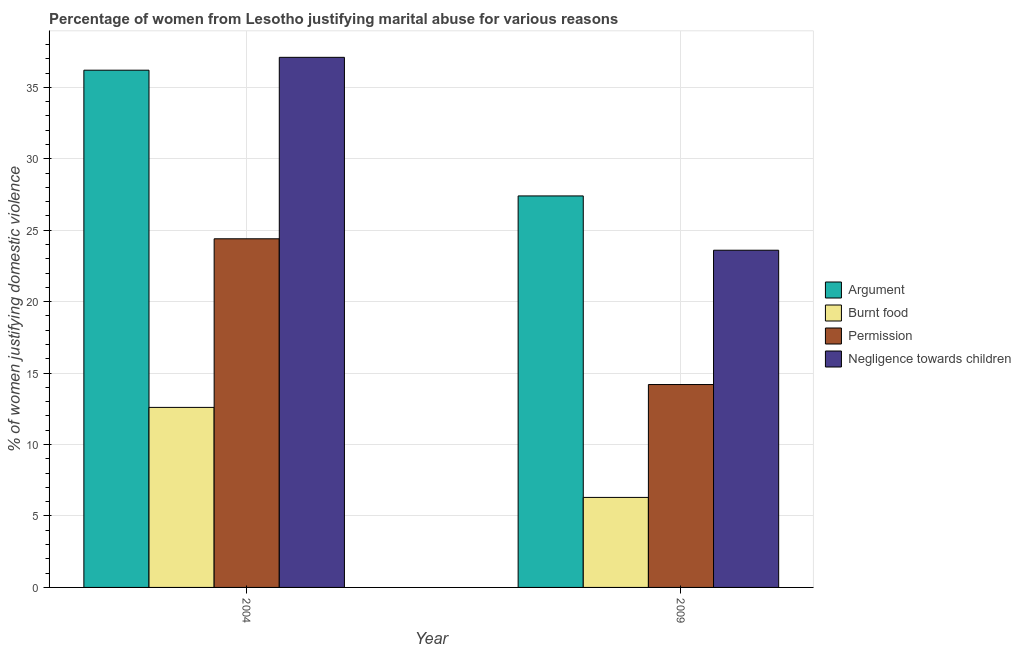How many different coloured bars are there?
Ensure brevity in your answer.  4. How many groups of bars are there?
Keep it short and to the point. 2. Are the number of bars on each tick of the X-axis equal?
Provide a succinct answer. Yes. How many bars are there on the 2nd tick from the left?
Offer a very short reply. 4. What is the label of the 1st group of bars from the left?
Make the answer very short. 2004. What is the percentage of women justifying abuse for showing negligence towards children in 2004?
Keep it short and to the point. 37.1. Across all years, what is the maximum percentage of women justifying abuse for going without permission?
Provide a short and direct response. 24.4. Across all years, what is the minimum percentage of women justifying abuse in the case of an argument?
Provide a succinct answer. 27.4. In which year was the percentage of women justifying abuse for burning food maximum?
Offer a very short reply. 2004. In which year was the percentage of women justifying abuse for showing negligence towards children minimum?
Keep it short and to the point. 2009. What is the total percentage of women justifying abuse for showing negligence towards children in the graph?
Your answer should be compact. 60.7. What is the average percentage of women justifying abuse for burning food per year?
Your response must be concise. 9.45. In the year 2009, what is the difference between the percentage of women justifying abuse for going without permission and percentage of women justifying abuse in the case of an argument?
Offer a terse response. 0. What is the ratio of the percentage of women justifying abuse in the case of an argument in 2004 to that in 2009?
Your answer should be compact. 1.32. In how many years, is the percentage of women justifying abuse for going without permission greater than the average percentage of women justifying abuse for going without permission taken over all years?
Give a very brief answer. 1. What does the 3rd bar from the left in 2009 represents?
Keep it short and to the point. Permission. What does the 2nd bar from the right in 2009 represents?
Your answer should be very brief. Permission. How many years are there in the graph?
Your response must be concise. 2. Does the graph contain any zero values?
Offer a very short reply. No. Where does the legend appear in the graph?
Your answer should be compact. Center right. What is the title of the graph?
Give a very brief answer. Percentage of women from Lesotho justifying marital abuse for various reasons. What is the label or title of the X-axis?
Ensure brevity in your answer.  Year. What is the label or title of the Y-axis?
Give a very brief answer. % of women justifying domestic violence. What is the % of women justifying domestic violence in Argument in 2004?
Offer a terse response. 36.2. What is the % of women justifying domestic violence in Burnt food in 2004?
Offer a terse response. 12.6. What is the % of women justifying domestic violence of Permission in 2004?
Offer a terse response. 24.4. What is the % of women justifying domestic violence of Negligence towards children in 2004?
Provide a short and direct response. 37.1. What is the % of women justifying domestic violence of Argument in 2009?
Offer a terse response. 27.4. What is the % of women justifying domestic violence of Burnt food in 2009?
Make the answer very short. 6.3. What is the % of women justifying domestic violence of Permission in 2009?
Provide a succinct answer. 14.2. What is the % of women justifying domestic violence of Negligence towards children in 2009?
Your response must be concise. 23.6. Across all years, what is the maximum % of women justifying domestic violence of Argument?
Give a very brief answer. 36.2. Across all years, what is the maximum % of women justifying domestic violence in Permission?
Your answer should be compact. 24.4. Across all years, what is the maximum % of women justifying domestic violence in Negligence towards children?
Provide a short and direct response. 37.1. Across all years, what is the minimum % of women justifying domestic violence in Argument?
Keep it short and to the point. 27.4. Across all years, what is the minimum % of women justifying domestic violence of Negligence towards children?
Offer a terse response. 23.6. What is the total % of women justifying domestic violence of Argument in the graph?
Make the answer very short. 63.6. What is the total % of women justifying domestic violence of Burnt food in the graph?
Offer a terse response. 18.9. What is the total % of women justifying domestic violence in Permission in the graph?
Provide a succinct answer. 38.6. What is the total % of women justifying domestic violence in Negligence towards children in the graph?
Your answer should be very brief. 60.7. What is the difference between the % of women justifying domestic violence of Burnt food in 2004 and that in 2009?
Your response must be concise. 6.3. What is the difference between the % of women justifying domestic violence of Permission in 2004 and that in 2009?
Make the answer very short. 10.2. What is the difference between the % of women justifying domestic violence of Negligence towards children in 2004 and that in 2009?
Your response must be concise. 13.5. What is the difference between the % of women justifying domestic violence in Argument in 2004 and the % of women justifying domestic violence in Burnt food in 2009?
Provide a succinct answer. 29.9. What is the difference between the % of women justifying domestic violence in Burnt food in 2004 and the % of women justifying domestic violence in Permission in 2009?
Ensure brevity in your answer.  -1.6. What is the difference between the % of women justifying domestic violence in Permission in 2004 and the % of women justifying domestic violence in Negligence towards children in 2009?
Your response must be concise. 0.8. What is the average % of women justifying domestic violence of Argument per year?
Your response must be concise. 31.8. What is the average % of women justifying domestic violence in Burnt food per year?
Your response must be concise. 9.45. What is the average % of women justifying domestic violence of Permission per year?
Provide a succinct answer. 19.3. What is the average % of women justifying domestic violence of Negligence towards children per year?
Your response must be concise. 30.35. In the year 2004, what is the difference between the % of women justifying domestic violence in Argument and % of women justifying domestic violence in Burnt food?
Provide a succinct answer. 23.6. In the year 2004, what is the difference between the % of women justifying domestic violence in Argument and % of women justifying domestic violence in Negligence towards children?
Offer a terse response. -0.9. In the year 2004, what is the difference between the % of women justifying domestic violence in Burnt food and % of women justifying domestic violence in Negligence towards children?
Offer a very short reply. -24.5. In the year 2004, what is the difference between the % of women justifying domestic violence of Permission and % of women justifying domestic violence of Negligence towards children?
Ensure brevity in your answer.  -12.7. In the year 2009, what is the difference between the % of women justifying domestic violence of Argument and % of women justifying domestic violence of Burnt food?
Your answer should be very brief. 21.1. In the year 2009, what is the difference between the % of women justifying domestic violence of Argument and % of women justifying domestic violence of Permission?
Your answer should be compact. 13.2. In the year 2009, what is the difference between the % of women justifying domestic violence of Burnt food and % of women justifying domestic violence of Permission?
Your answer should be compact. -7.9. In the year 2009, what is the difference between the % of women justifying domestic violence of Burnt food and % of women justifying domestic violence of Negligence towards children?
Offer a terse response. -17.3. In the year 2009, what is the difference between the % of women justifying domestic violence of Permission and % of women justifying domestic violence of Negligence towards children?
Provide a succinct answer. -9.4. What is the ratio of the % of women justifying domestic violence in Argument in 2004 to that in 2009?
Provide a succinct answer. 1.32. What is the ratio of the % of women justifying domestic violence of Burnt food in 2004 to that in 2009?
Keep it short and to the point. 2. What is the ratio of the % of women justifying domestic violence of Permission in 2004 to that in 2009?
Make the answer very short. 1.72. What is the ratio of the % of women justifying domestic violence in Negligence towards children in 2004 to that in 2009?
Your answer should be very brief. 1.57. What is the difference between the highest and the lowest % of women justifying domestic violence of Argument?
Offer a terse response. 8.8. What is the difference between the highest and the lowest % of women justifying domestic violence in Burnt food?
Offer a very short reply. 6.3. 